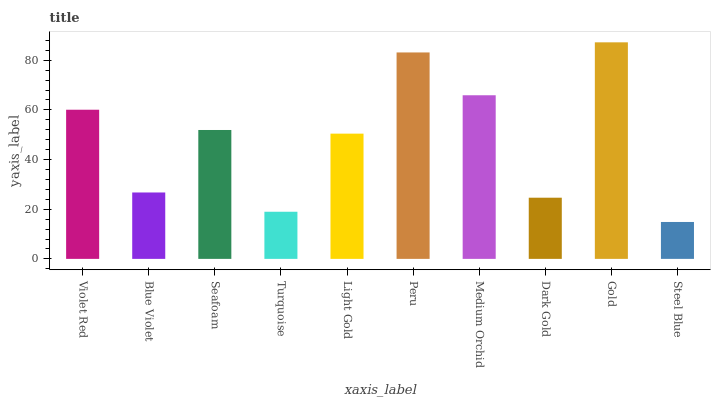Is Steel Blue the minimum?
Answer yes or no. Yes. Is Gold the maximum?
Answer yes or no. Yes. Is Blue Violet the minimum?
Answer yes or no. No. Is Blue Violet the maximum?
Answer yes or no. No. Is Violet Red greater than Blue Violet?
Answer yes or no. Yes. Is Blue Violet less than Violet Red?
Answer yes or no. Yes. Is Blue Violet greater than Violet Red?
Answer yes or no. No. Is Violet Red less than Blue Violet?
Answer yes or no. No. Is Seafoam the high median?
Answer yes or no. Yes. Is Light Gold the low median?
Answer yes or no. Yes. Is Turquoise the high median?
Answer yes or no. No. Is Medium Orchid the low median?
Answer yes or no. No. 